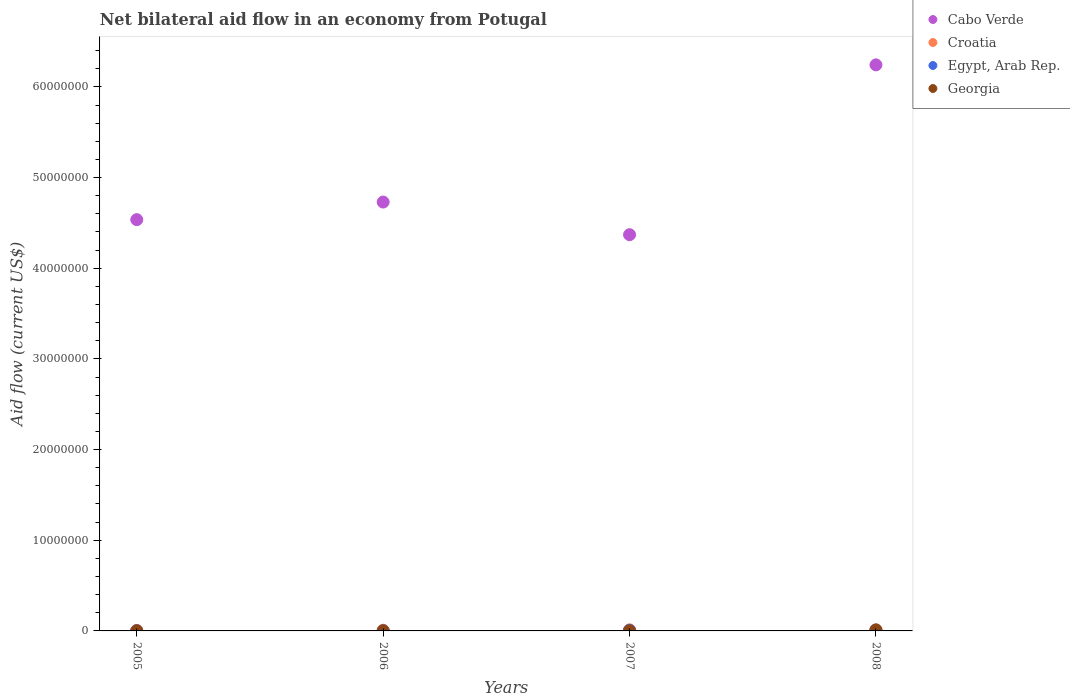Is the number of dotlines equal to the number of legend labels?
Your answer should be compact. Yes. Across all years, what is the maximum net bilateral aid flow in Georgia?
Give a very brief answer. 1.00e+05. What is the total net bilateral aid flow in Cabo Verde in the graph?
Your response must be concise. 1.99e+08. What is the difference between the net bilateral aid flow in Cabo Verde in 2007 and that in 2008?
Your answer should be compact. -1.87e+07. What is the difference between the net bilateral aid flow in Egypt, Arab Rep. in 2006 and the net bilateral aid flow in Cabo Verde in 2007?
Provide a succinct answer. -4.37e+07. What is the average net bilateral aid flow in Georgia per year?
Provide a succinct answer. 3.25e+04. In the year 2007, what is the difference between the net bilateral aid flow in Croatia and net bilateral aid flow in Georgia?
Your answer should be very brief. 1.10e+05. In how many years, is the net bilateral aid flow in Cabo Verde greater than 2000000 US$?
Offer a very short reply. 4. Is the net bilateral aid flow in Georgia in 2007 less than that in 2008?
Give a very brief answer. Yes. In how many years, is the net bilateral aid flow in Egypt, Arab Rep. greater than the average net bilateral aid flow in Egypt, Arab Rep. taken over all years?
Offer a terse response. 2. Does the net bilateral aid flow in Cabo Verde monotonically increase over the years?
Provide a short and direct response. No. How many years are there in the graph?
Your answer should be very brief. 4. Does the graph contain any zero values?
Your answer should be compact. No. Does the graph contain grids?
Your answer should be very brief. No. How many legend labels are there?
Your answer should be compact. 4. How are the legend labels stacked?
Offer a terse response. Vertical. What is the title of the graph?
Make the answer very short. Net bilateral aid flow in an economy from Potugal. Does "Middle income" appear as one of the legend labels in the graph?
Provide a succinct answer. No. What is the label or title of the Y-axis?
Give a very brief answer. Aid flow (current US$). What is the Aid flow (current US$) in Cabo Verde in 2005?
Provide a succinct answer. 4.54e+07. What is the Aid flow (current US$) in Croatia in 2005?
Give a very brief answer. 5.00e+04. What is the Aid flow (current US$) of Georgia in 2005?
Your answer should be very brief. 10000. What is the Aid flow (current US$) in Cabo Verde in 2006?
Your response must be concise. 4.73e+07. What is the Aid flow (current US$) of Egypt, Arab Rep. in 2006?
Keep it short and to the point. 10000. What is the Aid flow (current US$) of Cabo Verde in 2007?
Make the answer very short. 4.37e+07. What is the Aid flow (current US$) in Croatia in 2007?
Your answer should be very brief. 1.20e+05. What is the Aid flow (current US$) in Cabo Verde in 2008?
Your answer should be very brief. 6.24e+07. What is the Aid flow (current US$) of Georgia in 2008?
Make the answer very short. 1.00e+05. Across all years, what is the maximum Aid flow (current US$) in Cabo Verde?
Your answer should be very brief. 6.24e+07. Across all years, what is the maximum Aid flow (current US$) in Croatia?
Offer a very short reply. 1.20e+05. Across all years, what is the maximum Aid flow (current US$) in Egypt, Arab Rep.?
Offer a very short reply. 9.00e+04. Across all years, what is the minimum Aid flow (current US$) of Cabo Verde?
Give a very brief answer. 4.37e+07. Across all years, what is the minimum Aid flow (current US$) in Egypt, Arab Rep.?
Provide a succinct answer. 10000. Across all years, what is the minimum Aid flow (current US$) of Georgia?
Provide a succinct answer. 10000. What is the total Aid flow (current US$) in Cabo Verde in the graph?
Your response must be concise. 1.99e+08. What is the total Aid flow (current US$) in Croatia in the graph?
Provide a short and direct response. 3.70e+05. What is the difference between the Aid flow (current US$) in Cabo Verde in 2005 and that in 2006?
Your response must be concise. -1.94e+06. What is the difference between the Aid flow (current US$) in Croatia in 2005 and that in 2006?
Your answer should be very brief. -3.00e+04. What is the difference between the Aid flow (current US$) of Cabo Verde in 2005 and that in 2007?
Offer a very short reply. 1.66e+06. What is the difference between the Aid flow (current US$) of Cabo Verde in 2005 and that in 2008?
Keep it short and to the point. -1.71e+07. What is the difference between the Aid flow (current US$) in Egypt, Arab Rep. in 2005 and that in 2008?
Keep it short and to the point. -7.00e+04. What is the difference between the Aid flow (current US$) of Georgia in 2005 and that in 2008?
Keep it short and to the point. -9.00e+04. What is the difference between the Aid flow (current US$) of Cabo Verde in 2006 and that in 2007?
Your answer should be very brief. 3.60e+06. What is the difference between the Aid flow (current US$) of Cabo Verde in 2006 and that in 2008?
Your answer should be compact. -1.51e+07. What is the difference between the Aid flow (current US$) in Egypt, Arab Rep. in 2006 and that in 2008?
Provide a succinct answer. -8.00e+04. What is the difference between the Aid flow (current US$) of Cabo Verde in 2007 and that in 2008?
Make the answer very short. -1.87e+07. What is the difference between the Aid flow (current US$) of Croatia in 2007 and that in 2008?
Give a very brief answer. 0. What is the difference between the Aid flow (current US$) in Georgia in 2007 and that in 2008?
Keep it short and to the point. -9.00e+04. What is the difference between the Aid flow (current US$) of Cabo Verde in 2005 and the Aid flow (current US$) of Croatia in 2006?
Your answer should be very brief. 4.53e+07. What is the difference between the Aid flow (current US$) in Cabo Verde in 2005 and the Aid flow (current US$) in Egypt, Arab Rep. in 2006?
Ensure brevity in your answer.  4.54e+07. What is the difference between the Aid flow (current US$) of Cabo Verde in 2005 and the Aid flow (current US$) of Georgia in 2006?
Offer a very short reply. 4.54e+07. What is the difference between the Aid flow (current US$) of Egypt, Arab Rep. in 2005 and the Aid flow (current US$) of Georgia in 2006?
Offer a terse response. 10000. What is the difference between the Aid flow (current US$) in Cabo Verde in 2005 and the Aid flow (current US$) in Croatia in 2007?
Ensure brevity in your answer.  4.52e+07. What is the difference between the Aid flow (current US$) in Cabo Verde in 2005 and the Aid flow (current US$) in Egypt, Arab Rep. in 2007?
Your response must be concise. 4.53e+07. What is the difference between the Aid flow (current US$) in Cabo Verde in 2005 and the Aid flow (current US$) in Georgia in 2007?
Ensure brevity in your answer.  4.54e+07. What is the difference between the Aid flow (current US$) in Cabo Verde in 2005 and the Aid flow (current US$) in Croatia in 2008?
Your answer should be compact. 4.52e+07. What is the difference between the Aid flow (current US$) of Cabo Verde in 2005 and the Aid flow (current US$) of Egypt, Arab Rep. in 2008?
Make the answer very short. 4.53e+07. What is the difference between the Aid flow (current US$) of Cabo Verde in 2005 and the Aid flow (current US$) of Georgia in 2008?
Offer a terse response. 4.53e+07. What is the difference between the Aid flow (current US$) of Croatia in 2005 and the Aid flow (current US$) of Egypt, Arab Rep. in 2008?
Make the answer very short. -4.00e+04. What is the difference between the Aid flow (current US$) of Cabo Verde in 2006 and the Aid flow (current US$) of Croatia in 2007?
Keep it short and to the point. 4.72e+07. What is the difference between the Aid flow (current US$) of Cabo Verde in 2006 and the Aid flow (current US$) of Egypt, Arab Rep. in 2007?
Your answer should be compact. 4.72e+07. What is the difference between the Aid flow (current US$) in Cabo Verde in 2006 and the Aid flow (current US$) in Georgia in 2007?
Make the answer very short. 4.73e+07. What is the difference between the Aid flow (current US$) in Cabo Verde in 2006 and the Aid flow (current US$) in Croatia in 2008?
Provide a short and direct response. 4.72e+07. What is the difference between the Aid flow (current US$) of Cabo Verde in 2006 and the Aid flow (current US$) of Egypt, Arab Rep. in 2008?
Provide a short and direct response. 4.72e+07. What is the difference between the Aid flow (current US$) of Cabo Verde in 2006 and the Aid flow (current US$) of Georgia in 2008?
Provide a succinct answer. 4.72e+07. What is the difference between the Aid flow (current US$) in Egypt, Arab Rep. in 2006 and the Aid flow (current US$) in Georgia in 2008?
Offer a terse response. -9.00e+04. What is the difference between the Aid flow (current US$) in Cabo Verde in 2007 and the Aid flow (current US$) in Croatia in 2008?
Give a very brief answer. 4.36e+07. What is the difference between the Aid flow (current US$) in Cabo Verde in 2007 and the Aid flow (current US$) in Egypt, Arab Rep. in 2008?
Give a very brief answer. 4.36e+07. What is the difference between the Aid flow (current US$) of Cabo Verde in 2007 and the Aid flow (current US$) of Georgia in 2008?
Give a very brief answer. 4.36e+07. What is the difference between the Aid flow (current US$) of Croatia in 2007 and the Aid flow (current US$) of Georgia in 2008?
Your answer should be compact. 2.00e+04. What is the average Aid flow (current US$) of Cabo Verde per year?
Offer a very short reply. 4.97e+07. What is the average Aid flow (current US$) of Croatia per year?
Ensure brevity in your answer.  9.25e+04. What is the average Aid flow (current US$) in Egypt, Arab Rep. per year?
Ensure brevity in your answer.  4.75e+04. What is the average Aid flow (current US$) of Georgia per year?
Offer a very short reply. 3.25e+04. In the year 2005, what is the difference between the Aid flow (current US$) in Cabo Verde and Aid flow (current US$) in Croatia?
Provide a short and direct response. 4.53e+07. In the year 2005, what is the difference between the Aid flow (current US$) in Cabo Verde and Aid flow (current US$) in Egypt, Arab Rep.?
Your response must be concise. 4.53e+07. In the year 2005, what is the difference between the Aid flow (current US$) of Cabo Verde and Aid flow (current US$) of Georgia?
Ensure brevity in your answer.  4.54e+07. In the year 2005, what is the difference between the Aid flow (current US$) of Croatia and Aid flow (current US$) of Georgia?
Ensure brevity in your answer.  4.00e+04. In the year 2006, what is the difference between the Aid flow (current US$) of Cabo Verde and Aid flow (current US$) of Croatia?
Keep it short and to the point. 4.72e+07. In the year 2006, what is the difference between the Aid flow (current US$) in Cabo Verde and Aid flow (current US$) in Egypt, Arab Rep.?
Your answer should be compact. 4.73e+07. In the year 2006, what is the difference between the Aid flow (current US$) in Cabo Verde and Aid flow (current US$) in Georgia?
Provide a succinct answer. 4.73e+07. In the year 2006, what is the difference between the Aid flow (current US$) of Croatia and Aid flow (current US$) of Egypt, Arab Rep.?
Provide a short and direct response. 7.00e+04. In the year 2006, what is the difference between the Aid flow (current US$) of Croatia and Aid flow (current US$) of Georgia?
Provide a succinct answer. 7.00e+04. In the year 2007, what is the difference between the Aid flow (current US$) in Cabo Verde and Aid flow (current US$) in Croatia?
Make the answer very short. 4.36e+07. In the year 2007, what is the difference between the Aid flow (current US$) of Cabo Verde and Aid flow (current US$) of Egypt, Arab Rep.?
Give a very brief answer. 4.36e+07. In the year 2007, what is the difference between the Aid flow (current US$) in Cabo Verde and Aid flow (current US$) in Georgia?
Your response must be concise. 4.37e+07. In the year 2007, what is the difference between the Aid flow (current US$) in Croatia and Aid flow (current US$) in Georgia?
Ensure brevity in your answer.  1.10e+05. In the year 2007, what is the difference between the Aid flow (current US$) of Egypt, Arab Rep. and Aid flow (current US$) of Georgia?
Keep it short and to the point. 6.00e+04. In the year 2008, what is the difference between the Aid flow (current US$) of Cabo Verde and Aid flow (current US$) of Croatia?
Ensure brevity in your answer.  6.23e+07. In the year 2008, what is the difference between the Aid flow (current US$) of Cabo Verde and Aid flow (current US$) of Egypt, Arab Rep.?
Offer a very short reply. 6.23e+07. In the year 2008, what is the difference between the Aid flow (current US$) in Cabo Verde and Aid flow (current US$) in Georgia?
Your response must be concise. 6.23e+07. In the year 2008, what is the difference between the Aid flow (current US$) in Egypt, Arab Rep. and Aid flow (current US$) in Georgia?
Your answer should be very brief. -10000. What is the ratio of the Aid flow (current US$) of Croatia in 2005 to that in 2006?
Offer a very short reply. 0.62. What is the ratio of the Aid flow (current US$) of Georgia in 2005 to that in 2006?
Your answer should be very brief. 1. What is the ratio of the Aid flow (current US$) of Cabo Verde in 2005 to that in 2007?
Provide a short and direct response. 1.04. What is the ratio of the Aid flow (current US$) in Croatia in 2005 to that in 2007?
Your answer should be compact. 0.42. What is the ratio of the Aid flow (current US$) of Egypt, Arab Rep. in 2005 to that in 2007?
Your response must be concise. 0.29. What is the ratio of the Aid flow (current US$) in Cabo Verde in 2005 to that in 2008?
Make the answer very short. 0.73. What is the ratio of the Aid flow (current US$) in Croatia in 2005 to that in 2008?
Your answer should be compact. 0.42. What is the ratio of the Aid flow (current US$) of Egypt, Arab Rep. in 2005 to that in 2008?
Give a very brief answer. 0.22. What is the ratio of the Aid flow (current US$) in Georgia in 2005 to that in 2008?
Provide a succinct answer. 0.1. What is the ratio of the Aid flow (current US$) in Cabo Verde in 2006 to that in 2007?
Your answer should be very brief. 1.08. What is the ratio of the Aid flow (current US$) of Egypt, Arab Rep. in 2006 to that in 2007?
Give a very brief answer. 0.14. What is the ratio of the Aid flow (current US$) of Georgia in 2006 to that in 2007?
Your answer should be compact. 1. What is the ratio of the Aid flow (current US$) of Cabo Verde in 2006 to that in 2008?
Give a very brief answer. 0.76. What is the ratio of the Aid flow (current US$) in Croatia in 2006 to that in 2008?
Your answer should be compact. 0.67. What is the ratio of the Aid flow (current US$) of Cabo Verde in 2007 to that in 2008?
Offer a very short reply. 0.7. What is the ratio of the Aid flow (current US$) of Croatia in 2007 to that in 2008?
Provide a short and direct response. 1. What is the ratio of the Aid flow (current US$) in Egypt, Arab Rep. in 2007 to that in 2008?
Your answer should be very brief. 0.78. What is the ratio of the Aid flow (current US$) in Georgia in 2007 to that in 2008?
Provide a short and direct response. 0.1. What is the difference between the highest and the second highest Aid flow (current US$) in Cabo Verde?
Provide a short and direct response. 1.51e+07. What is the difference between the highest and the second highest Aid flow (current US$) of Egypt, Arab Rep.?
Provide a succinct answer. 2.00e+04. What is the difference between the highest and the second highest Aid flow (current US$) in Georgia?
Give a very brief answer. 9.00e+04. What is the difference between the highest and the lowest Aid flow (current US$) of Cabo Verde?
Offer a very short reply. 1.87e+07. What is the difference between the highest and the lowest Aid flow (current US$) of Egypt, Arab Rep.?
Your answer should be very brief. 8.00e+04. 